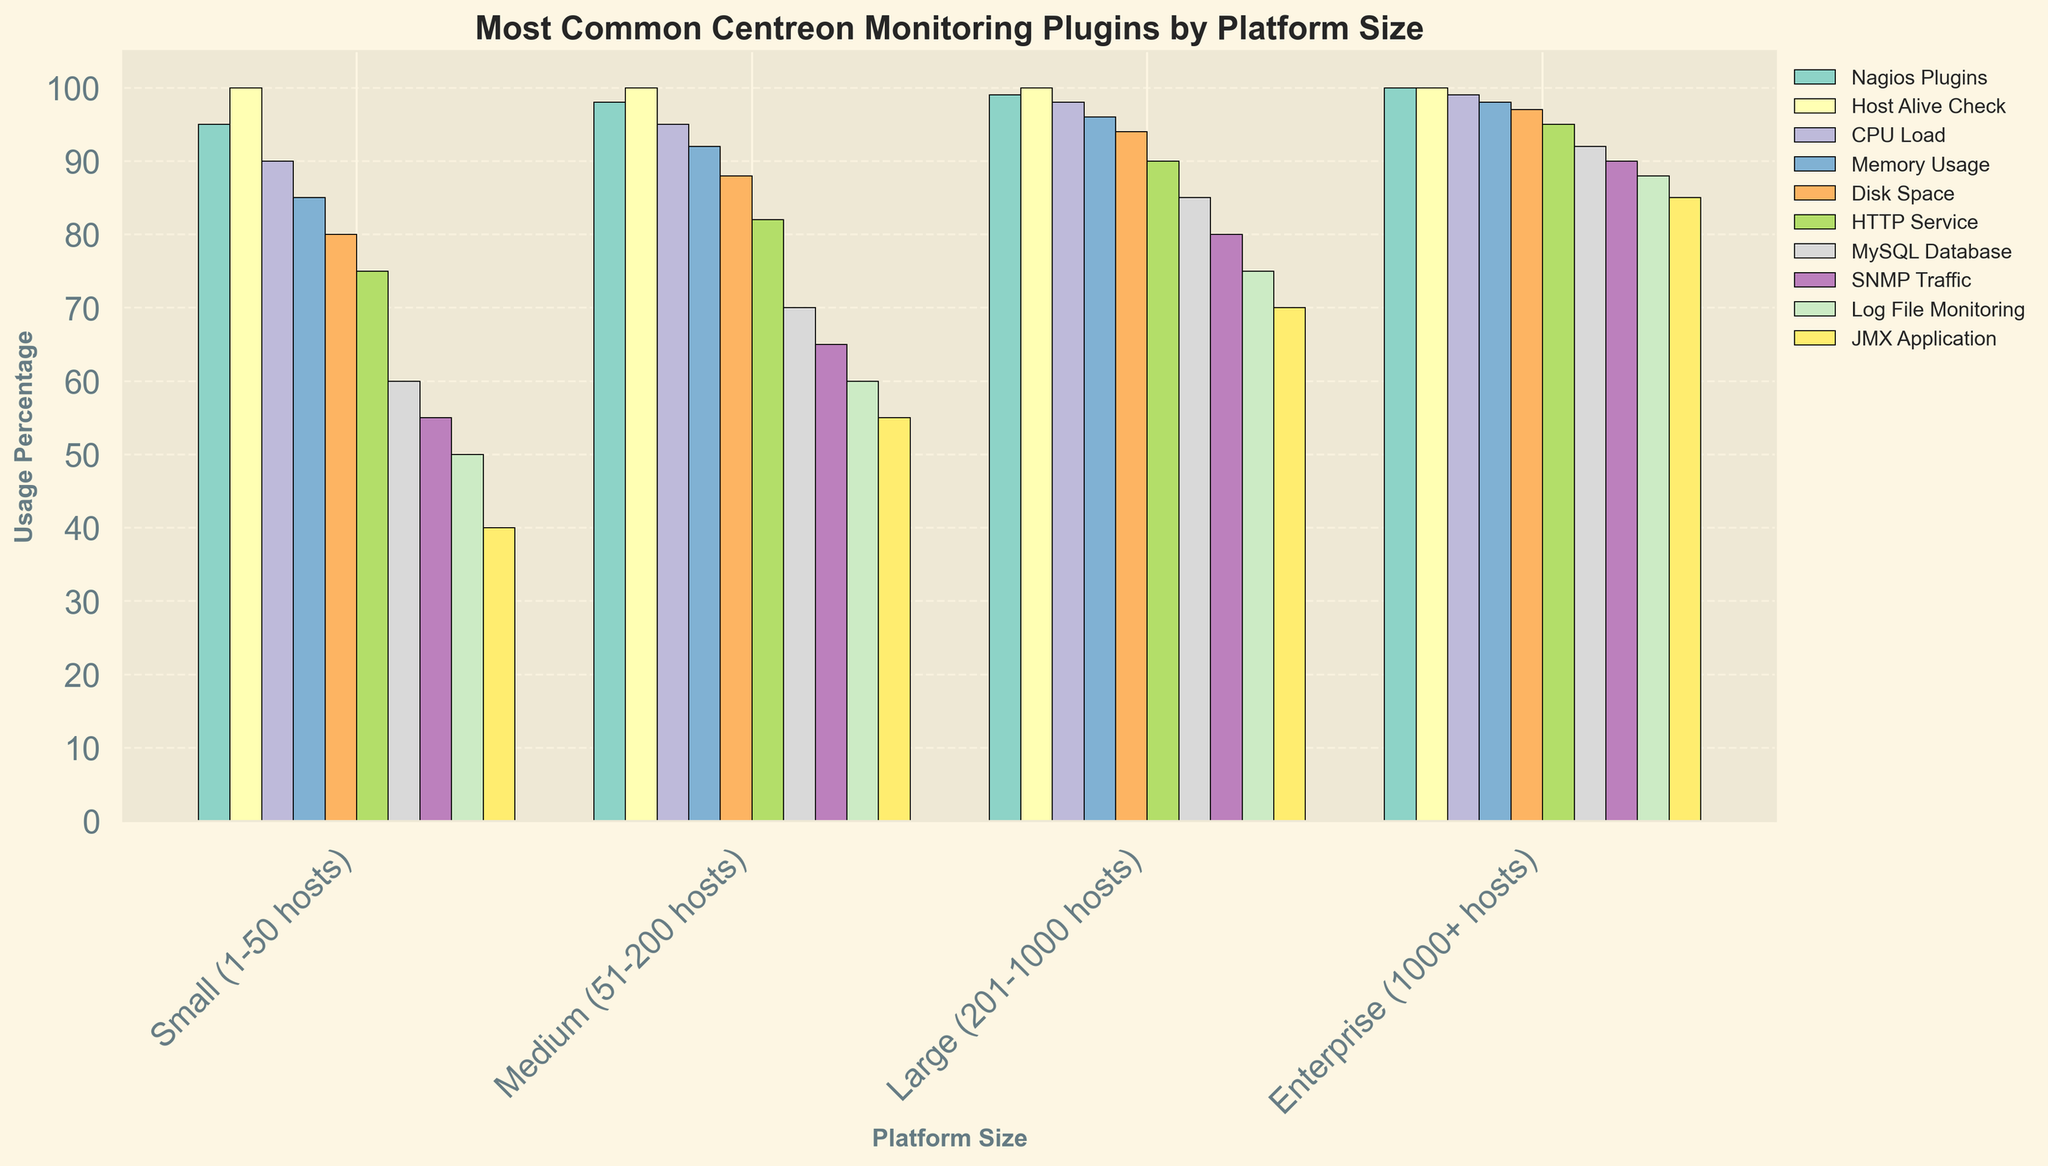Which Centreon monitoring plugin has the highest usage percentage across all platform sizes? By analyzing the figure, the "Host Alive Check" plugin consistently shows a 100% usage percentage across all platform sizes. Simply check the highest bar across all categories.
Answer: Host Alive Check Which platform size uses the "MySQL Database" plugin the least? By looking at the height of the "MySQL Database" bars, the smallest percentage appears for "Small (1-50 hosts)" with 60%.
Answer: Small (1-50 hosts) What is the difference in the usage percentage of the "CPU Load" plugin between Small and Enterprise platform sizes? For "CPU Load", Small platforms have 90% usage while Enterprise platforms have 99%. The difference is 99% - 90% = 9%.
Answer: 9% On average, what percentage of Medium-sized platforms use the "Disk Space" and "HTTP Service" plugins? For Medium platforms, "Disk Space" is 88% and "HTTP Service" is 82%. Average = (88% + 82%) / 2 = 85%.
Answer: 85% Which plugin sees the most significant increase in usage percentage from Small to Large platform sizes? By comparing the bars from Small to Large, the "SNMP Traffic" plugin increases from 55% to 80%, the largest jump of 25%.
Answer: SNMP Traffic How does the usage of the "Memory Usage" plugin compare between Medium and Enterprise platforms? Medium platforms have 92% usage for "Memory Usage", while Enterprise platforms have 98%. Enterprise platforms have a higher usage.
Answer: Enterprise What is the total usage percentage of all plugins for Large platforms? Summing the percentages for Large platforms: 99% + 100% + 98% + 96% + 94% + 90% + 85% + 80% + 75% + 70% gives 887%.
Answer: 887% Is the usage percentage of the "Log File Monitoring" plugin across all platform sizes increasing or decreasing as the platform size grows? Observing the "Log File Monitoring" bars, the usage increases from 50% to 88% as the platform size grows.
Answer: Increasing Which platform size utilizes the "JMX Application" plugin the most, and by what percentage more than the least utilizing size? Enterprise platforms use "JMX Application" 85%, the highest. Small platforms use it 40%, the lowest. Difference is 85% - 40% = 45%.
Answer: Enterprise, 45% 